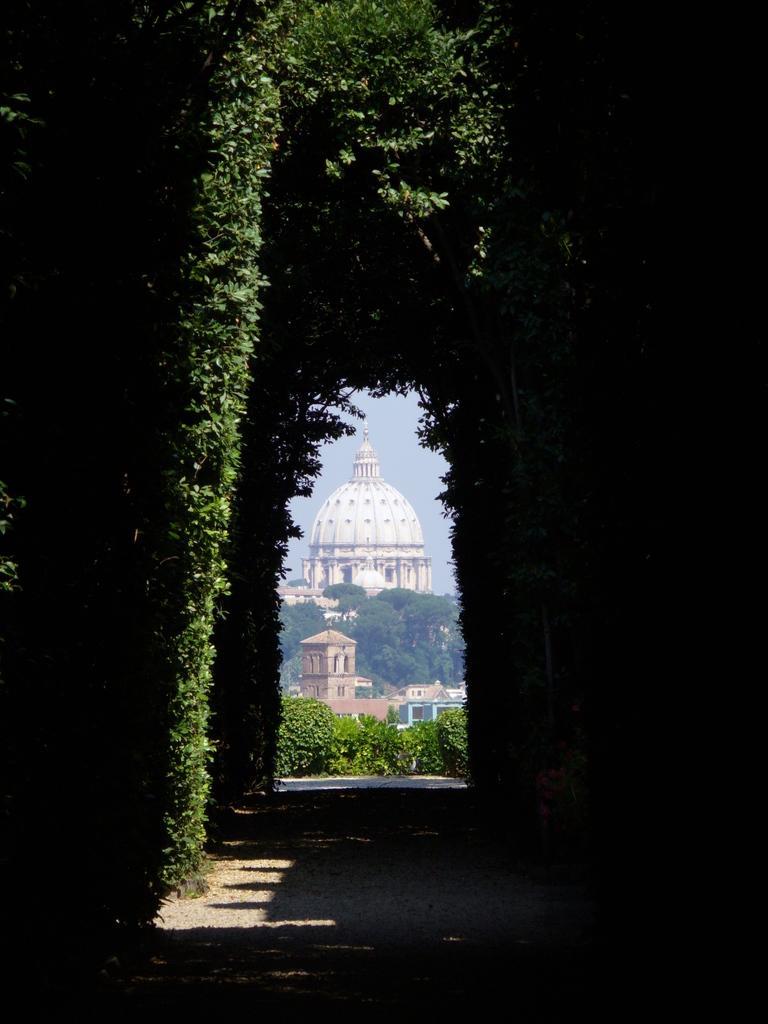In one or two sentences, can you explain what this image depicts? In the foreground of the picture there are trees and a walkway. In the middle of the picture we can see plants. In the background there are buildings, trees and sky. 